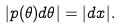<formula> <loc_0><loc_0><loc_500><loc_500>| p ( \theta ) d \theta | = | d x | .</formula> 